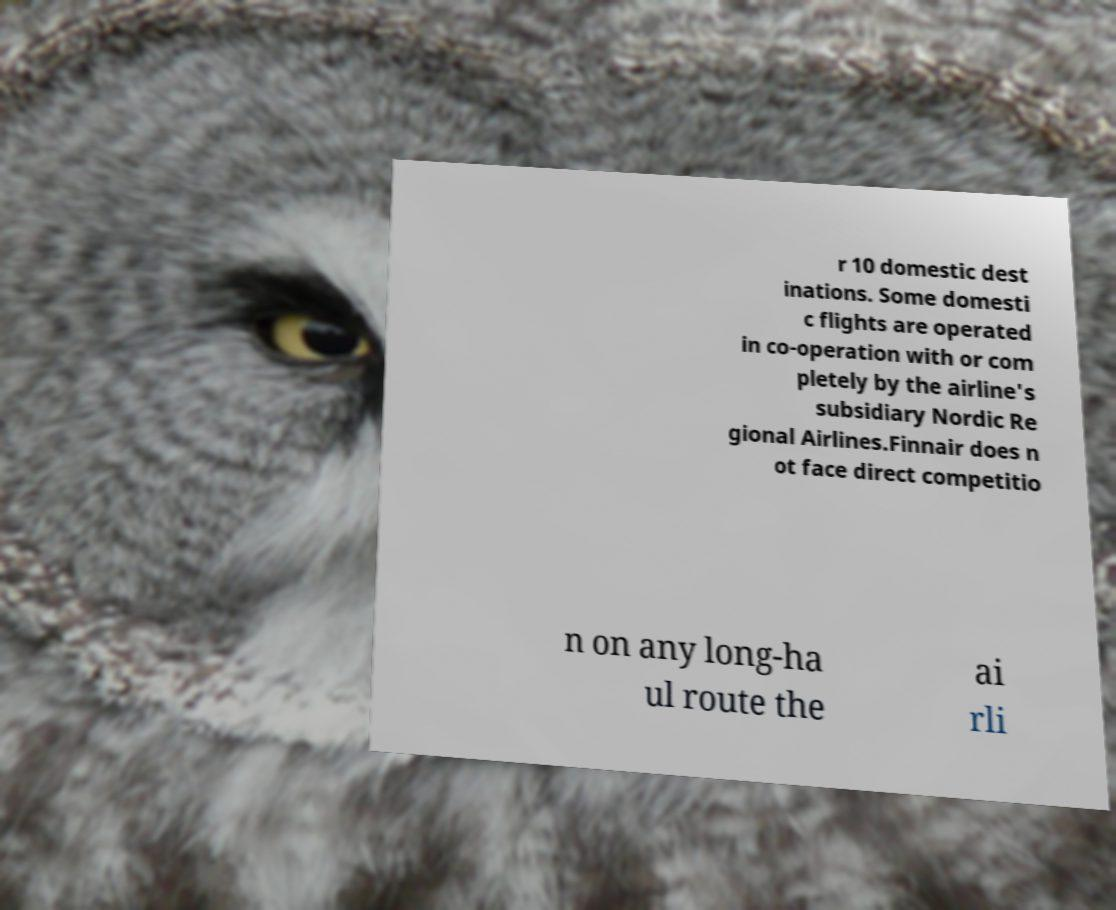Could you assist in decoding the text presented in this image and type it out clearly? r 10 domestic dest inations. Some domesti c flights are operated in co-operation with or com pletely by the airline's subsidiary Nordic Re gional Airlines.Finnair does n ot face direct competitio n on any long-ha ul route the ai rli 